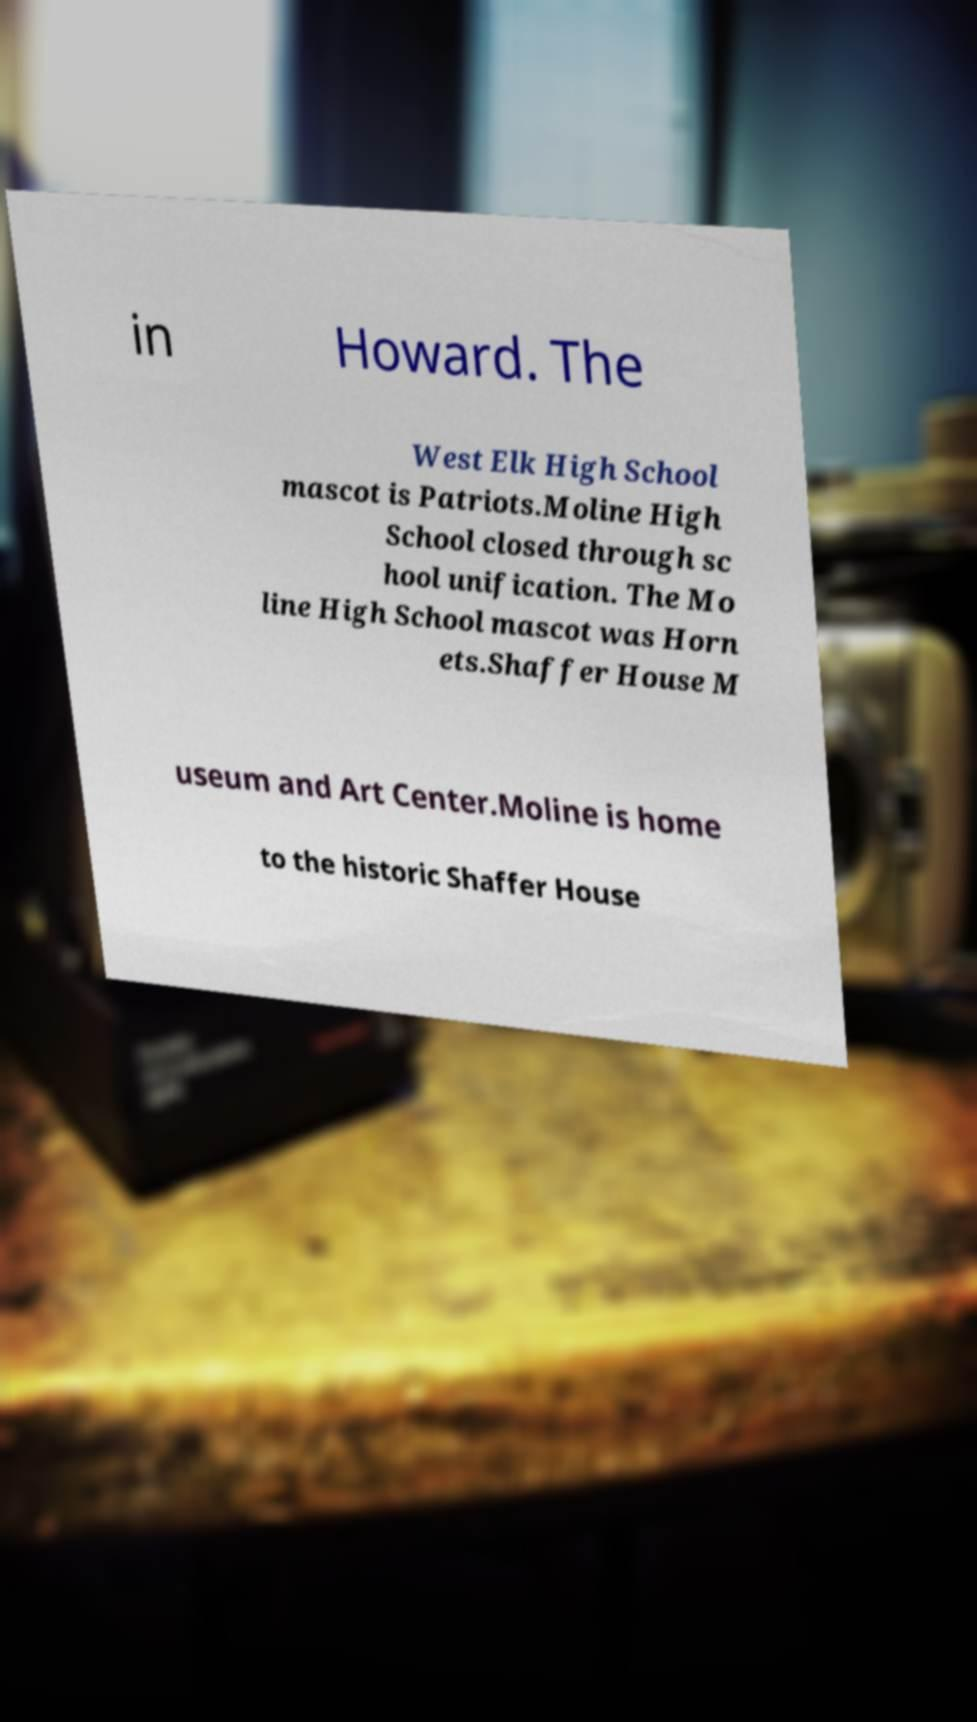Please read and relay the text visible in this image. What does it say? in Howard. The West Elk High School mascot is Patriots.Moline High School closed through sc hool unification. The Mo line High School mascot was Horn ets.Shaffer House M useum and Art Center.Moline is home to the historic Shaffer House 